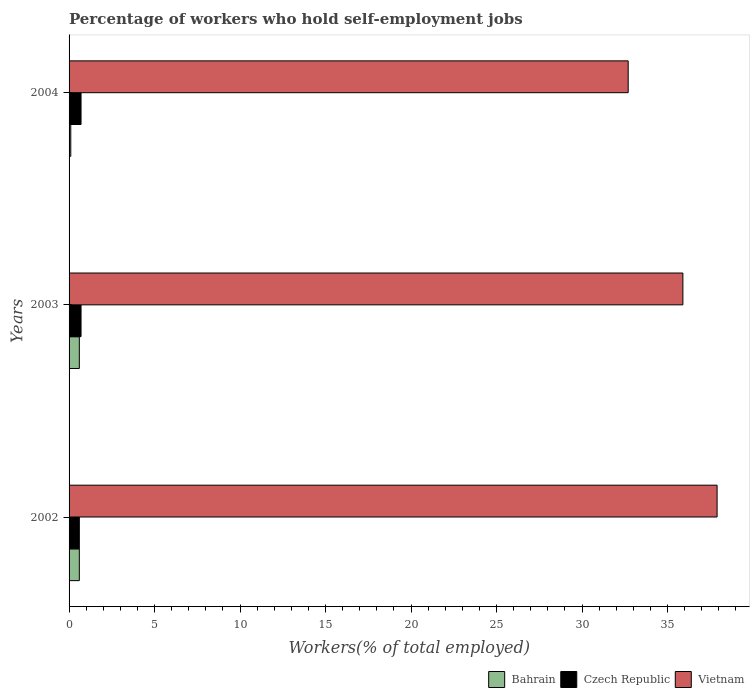How many different coloured bars are there?
Make the answer very short. 3. How many bars are there on the 1st tick from the top?
Your response must be concise. 3. What is the percentage of self-employed workers in Vietnam in 2003?
Offer a very short reply. 35.9. Across all years, what is the maximum percentage of self-employed workers in Bahrain?
Provide a succinct answer. 0.6. Across all years, what is the minimum percentage of self-employed workers in Vietnam?
Offer a terse response. 32.7. What is the total percentage of self-employed workers in Czech Republic in the graph?
Offer a terse response. 2. What is the difference between the percentage of self-employed workers in Bahrain in 2002 and that in 2003?
Offer a terse response. 0. What is the difference between the percentage of self-employed workers in Vietnam in 2004 and the percentage of self-employed workers in Bahrain in 2002?
Keep it short and to the point. 32.1. What is the average percentage of self-employed workers in Czech Republic per year?
Make the answer very short. 0.67. In the year 2003, what is the difference between the percentage of self-employed workers in Bahrain and percentage of self-employed workers in Czech Republic?
Provide a succinct answer. -0.1. What is the ratio of the percentage of self-employed workers in Czech Republic in 2002 to that in 2003?
Make the answer very short. 0.86. What is the difference between the highest and the second highest percentage of self-employed workers in Vietnam?
Provide a succinct answer. 2. What is the difference between the highest and the lowest percentage of self-employed workers in Czech Republic?
Offer a very short reply. 0.1. Is the sum of the percentage of self-employed workers in Bahrain in 2003 and 2004 greater than the maximum percentage of self-employed workers in Czech Republic across all years?
Give a very brief answer. Yes. What does the 2nd bar from the top in 2002 represents?
Ensure brevity in your answer.  Czech Republic. What does the 3rd bar from the bottom in 2003 represents?
Your response must be concise. Vietnam. Is it the case that in every year, the sum of the percentage of self-employed workers in Vietnam and percentage of self-employed workers in Czech Republic is greater than the percentage of self-employed workers in Bahrain?
Keep it short and to the point. Yes. What is the difference between two consecutive major ticks on the X-axis?
Provide a succinct answer. 5. Are the values on the major ticks of X-axis written in scientific E-notation?
Keep it short and to the point. No. Where does the legend appear in the graph?
Your answer should be very brief. Bottom right. How are the legend labels stacked?
Give a very brief answer. Horizontal. What is the title of the graph?
Provide a short and direct response. Percentage of workers who hold self-employment jobs. Does "Greenland" appear as one of the legend labels in the graph?
Offer a terse response. No. What is the label or title of the X-axis?
Make the answer very short. Workers(% of total employed). What is the Workers(% of total employed) in Bahrain in 2002?
Offer a very short reply. 0.6. What is the Workers(% of total employed) in Czech Republic in 2002?
Your answer should be very brief. 0.6. What is the Workers(% of total employed) of Vietnam in 2002?
Your answer should be compact. 37.9. What is the Workers(% of total employed) of Bahrain in 2003?
Give a very brief answer. 0.6. What is the Workers(% of total employed) of Czech Republic in 2003?
Offer a terse response. 0.7. What is the Workers(% of total employed) in Vietnam in 2003?
Your response must be concise. 35.9. What is the Workers(% of total employed) in Bahrain in 2004?
Ensure brevity in your answer.  0.1. What is the Workers(% of total employed) of Czech Republic in 2004?
Provide a succinct answer. 0.7. What is the Workers(% of total employed) in Vietnam in 2004?
Provide a succinct answer. 32.7. Across all years, what is the maximum Workers(% of total employed) in Bahrain?
Make the answer very short. 0.6. Across all years, what is the maximum Workers(% of total employed) of Czech Republic?
Offer a very short reply. 0.7. Across all years, what is the maximum Workers(% of total employed) in Vietnam?
Provide a short and direct response. 37.9. Across all years, what is the minimum Workers(% of total employed) in Bahrain?
Provide a short and direct response. 0.1. Across all years, what is the minimum Workers(% of total employed) of Czech Republic?
Provide a short and direct response. 0.6. Across all years, what is the minimum Workers(% of total employed) of Vietnam?
Provide a succinct answer. 32.7. What is the total Workers(% of total employed) in Bahrain in the graph?
Provide a short and direct response. 1.3. What is the total Workers(% of total employed) of Vietnam in the graph?
Provide a short and direct response. 106.5. What is the difference between the Workers(% of total employed) in Czech Republic in 2002 and that in 2003?
Make the answer very short. -0.1. What is the difference between the Workers(% of total employed) of Vietnam in 2002 and that in 2003?
Your response must be concise. 2. What is the difference between the Workers(% of total employed) of Vietnam in 2002 and that in 2004?
Offer a terse response. 5.2. What is the difference between the Workers(% of total employed) of Bahrain in 2002 and the Workers(% of total employed) of Czech Republic in 2003?
Offer a terse response. -0.1. What is the difference between the Workers(% of total employed) of Bahrain in 2002 and the Workers(% of total employed) of Vietnam in 2003?
Your answer should be compact. -35.3. What is the difference between the Workers(% of total employed) in Czech Republic in 2002 and the Workers(% of total employed) in Vietnam in 2003?
Offer a terse response. -35.3. What is the difference between the Workers(% of total employed) in Bahrain in 2002 and the Workers(% of total employed) in Czech Republic in 2004?
Give a very brief answer. -0.1. What is the difference between the Workers(% of total employed) in Bahrain in 2002 and the Workers(% of total employed) in Vietnam in 2004?
Your answer should be compact. -32.1. What is the difference between the Workers(% of total employed) in Czech Republic in 2002 and the Workers(% of total employed) in Vietnam in 2004?
Your response must be concise. -32.1. What is the difference between the Workers(% of total employed) of Bahrain in 2003 and the Workers(% of total employed) of Czech Republic in 2004?
Provide a succinct answer. -0.1. What is the difference between the Workers(% of total employed) of Bahrain in 2003 and the Workers(% of total employed) of Vietnam in 2004?
Make the answer very short. -32.1. What is the difference between the Workers(% of total employed) in Czech Republic in 2003 and the Workers(% of total employed) in Vietnam in 2004?
Provide a succinct answer. -32. What is the average Workers(% of total employed) of Bahrain per year?
Ensure brevity in your answer.  0.43. What is the average Workers(% of total employed) in Vietnam per year?
Make the answer very short. 35.5. In the year 2002, what is the difference between the Workers(% of total employed) of Bahrain and Workers(% of total employed) of Czech Republic?
Provide a succinct answer. 0. In the year 2002, what is the difference between the Workers(% of total employed) in Bahrain and Workers(% of total employed) in Vietnam?
Your response must be concise. -37.3. In the year 2002, what is the difference between the Workers(% of total employed) of Czech Republic and Workers(% of total employed) of Vietnam?
Offer a very short reply. -37.3. In the year 2003, what is the difference between the Workers(% of total employed) of Bahrain and Workers(% of total employed) of Vietnam?
Offer a terse response. -35.3. In the year 2003, what is the difference between the Workers(% of total employed) in Czech Republic and Workers(% of total employed) in Vietnam?
Keep it short and to the point. -35.2. In the year 2004, what is the difference between the Workers(% of total employed) of Bahrain and Workers(% of total employed) of Czech Republic?
Offer a terse response. -0.6. In the year 2004, what is the difference between the Workers(% of total employed) in Bahrain and Workers(% of total employed) in Vietnam?
Offer a very short reply. -32.6. In the year 2004, what is the difference between the Workers(% of total employed) in Czech Republic and Workers(% of total employed) in Vietnam?
Offer a terse response. -32. What is the ratio of the Workers(% of total employed) of Czech Republic in 2002 to that in 2003?
Give a very brief answer. 0.86. What is the ratio of the Workers(% of total employed) of Vietnam in 2002 to that in 2003?
Your answer should be very brief. 1.06. What is the ratio of the Workers(% of total employed) in Bahrain in 2002 to that in 2004?
Ensure brevity in your answer.  6. What is the ratio of the Workers(% of total employed) of Czech Republic in 2002 to that in 2004?
Provide a succinct answer. 0.86. What is the ratio of the Workers(% of total employed) of Vietnam in 2002 to that in 2004?
Make the answer very short. 1.16. What is the ratio of the Workers(% of total employed) of Vietnam in 2003 to that in 2004?
Keep it short and to the point. 1.1. What is the difference between the highest and the second highest Workers(% of total employed) in Vietnam?
Give a very brief answer. 2. What is the difference between the highest and the lowest Workers(% of total employed) of Vietnam?
Your answer should be compact. 5.2. 